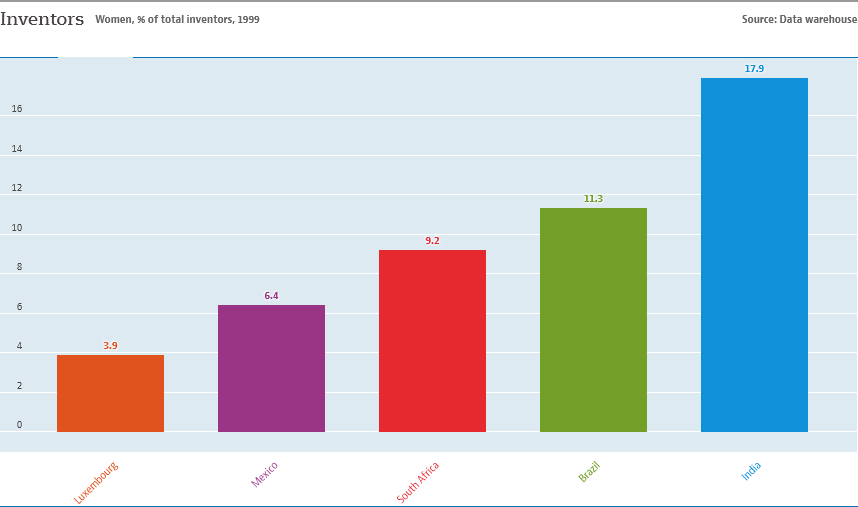Point out several critical features in this image. The value difference between South Africa and Brazil is 2.1. The red bar represents South Africa. 